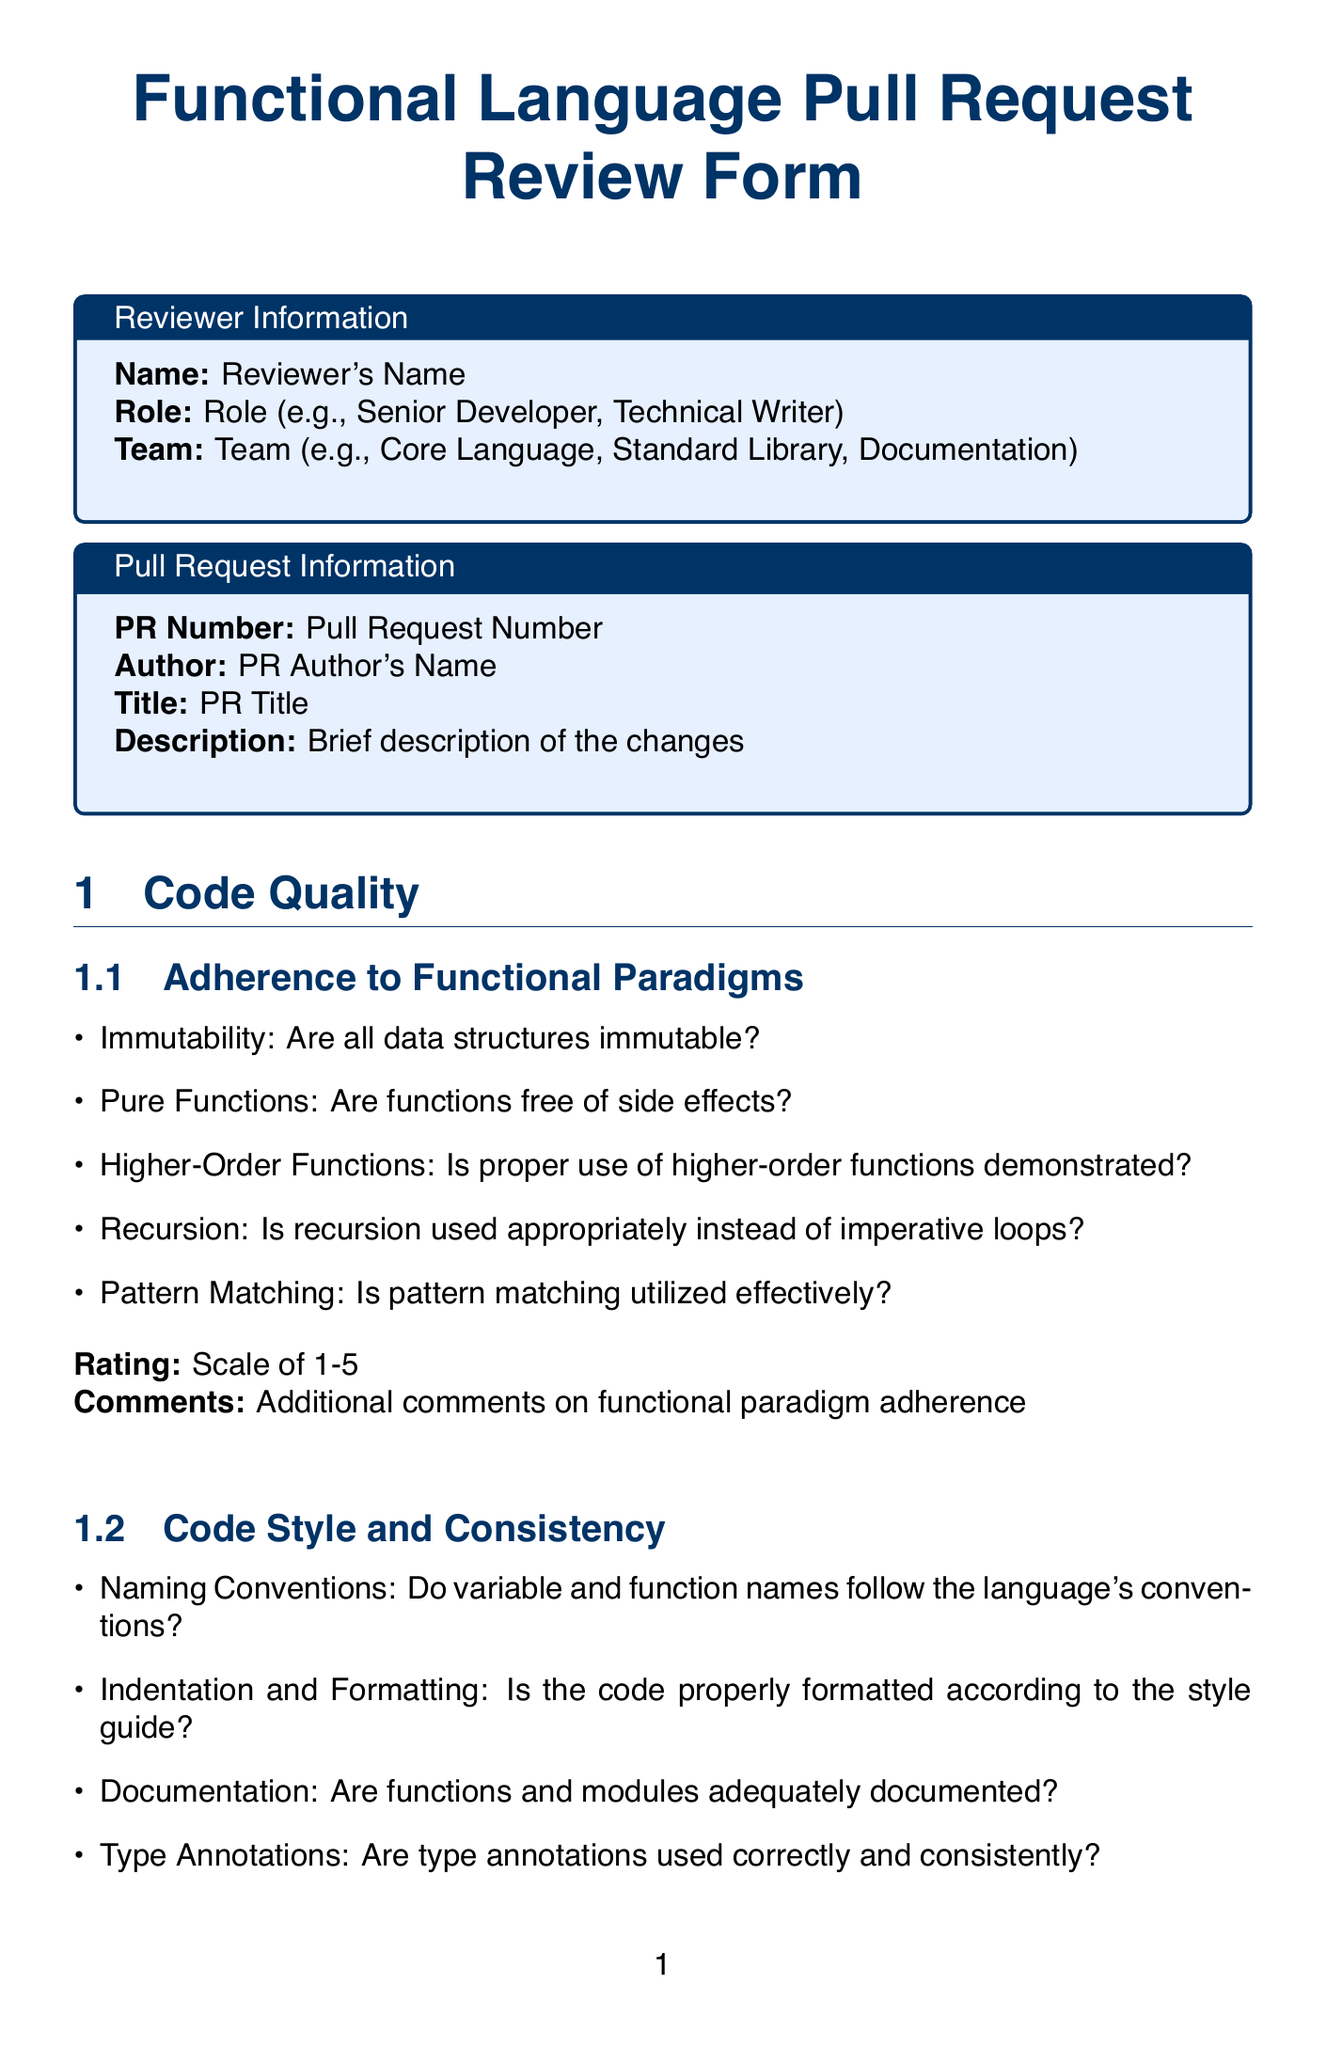What is the title of the document? The title is stated at the beginning of the document, which is "Functional Language Pull Request Review Form".
Answer: Functional Language Pull Request Review Form Who is responsible for assessing test coverage? The section titled "Test Coverage" outlines who should assess various aspects of testing in the review.
Answer: Reviewer What rating scale is used for code quality? The document specifies that the rating for aspects of code quality is a scale of 1-5.
Answer: Scale of 1-5 What changes are required in the user guide? The document inquires if any changes are necessary in the user guide, which is outlined in the "Documentation Impact" section.
Answer: Yes/No required What should the reviewer provide as a summary of the review? The overall assessment section asks for a summary to capture key review points that need addressing.
Answer: Summary of the review and main points to address Is there a section dedicated to performance impact analysis? The document includes a section that focuses specifically on performance impact, addressing various complexities.
Answer: Yes What type of changes are noted for the standard library? The document inquires whether there are any changes to the standard library in the "Language Features" section.
Answer: Yes/No required How does the reviewer assess the adherence to functional paradigms? The adherence to functional paradigms is evaluated through a list of specific criteria provided in the "Code Quality" section.
Answer: Based on criteria listed What decision options are available for the overall assessment? The overall assessment section lists options for the reviewer to choose from regarding the pull request.
Answer: Approve / Request Changes / Comment What is included in the next steps section of the document? The next steps section outlines required changes, optional improvements, and documentation tasks.
Answer: Required Changes / Optional Improvements / Documentation Tasks 